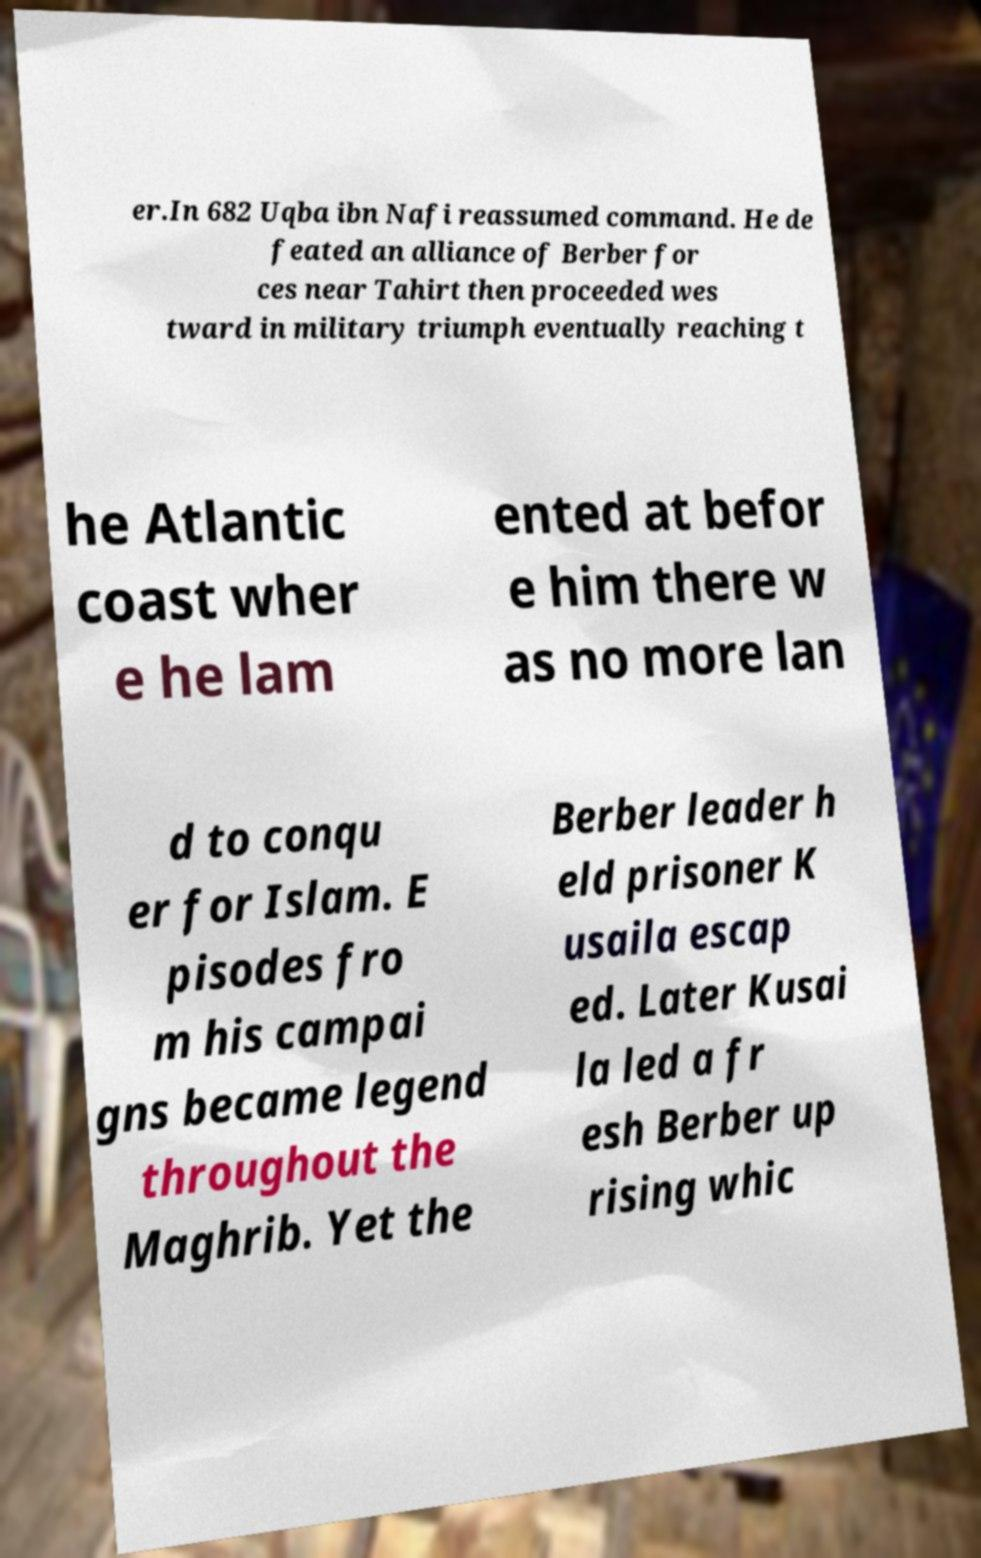For documentation purposes, I need the text within this image transcribed. Could you provide that? er.In 682 Uqba ibn Nafi reassumed command. He de feated an alliance of Berber for ces near Tahirt then proceeded wes tward in military triumph eventually reaching t he Atlantic coast wher e he lam ented at befor e him there w as no more lan d to conqu er for Islam. E pisodes fro m his campai gns became legend throughout the Maghrib. Yet the Berber leader h eld prisoner K usaila escap ed. Later Kusai la led a fr esh Berber up rising whic 